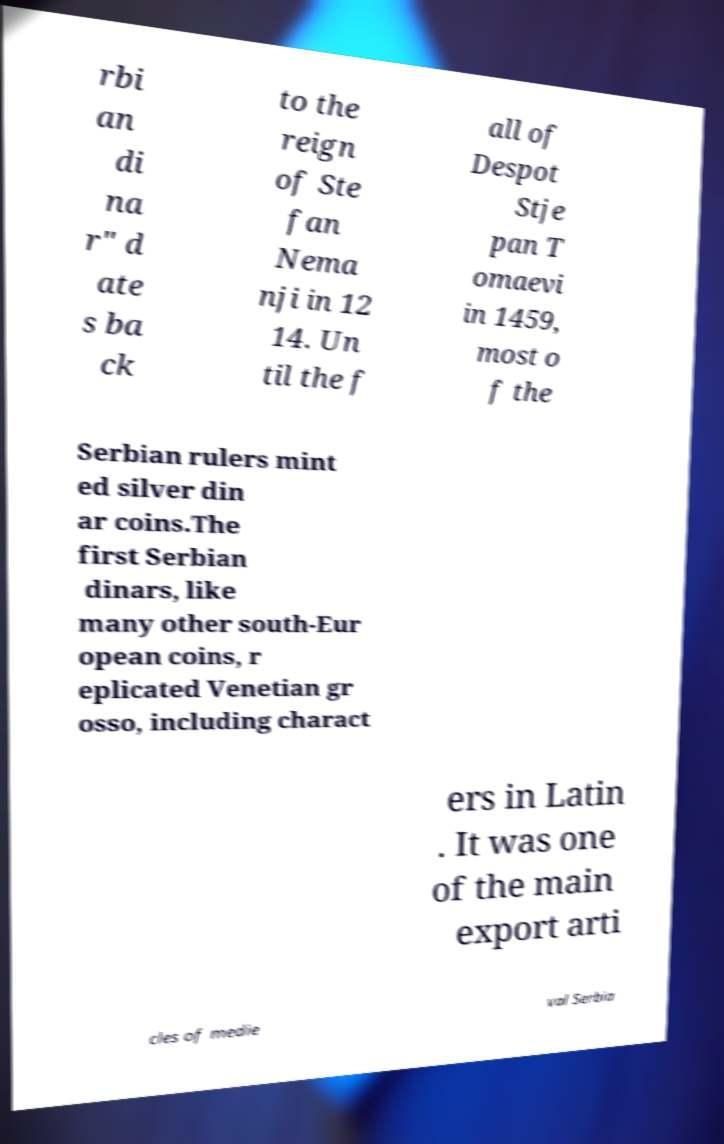I need the written content from this picture converted into text. Can you do that? rbi an di na r" d ate s ba ck to the reign of Ste fan Nema nji in 12 14. Un til the f all of Despot Stje pan T omaevi in 1459, most o f the Serbian rulers mint ed silver din ar coins.The first Serbian dinars, like many other south-Eur opean coins, r eplicated Venetian gr osso, including charact ers in Latin . It was one of the main export arti cles of medie val Serbia 